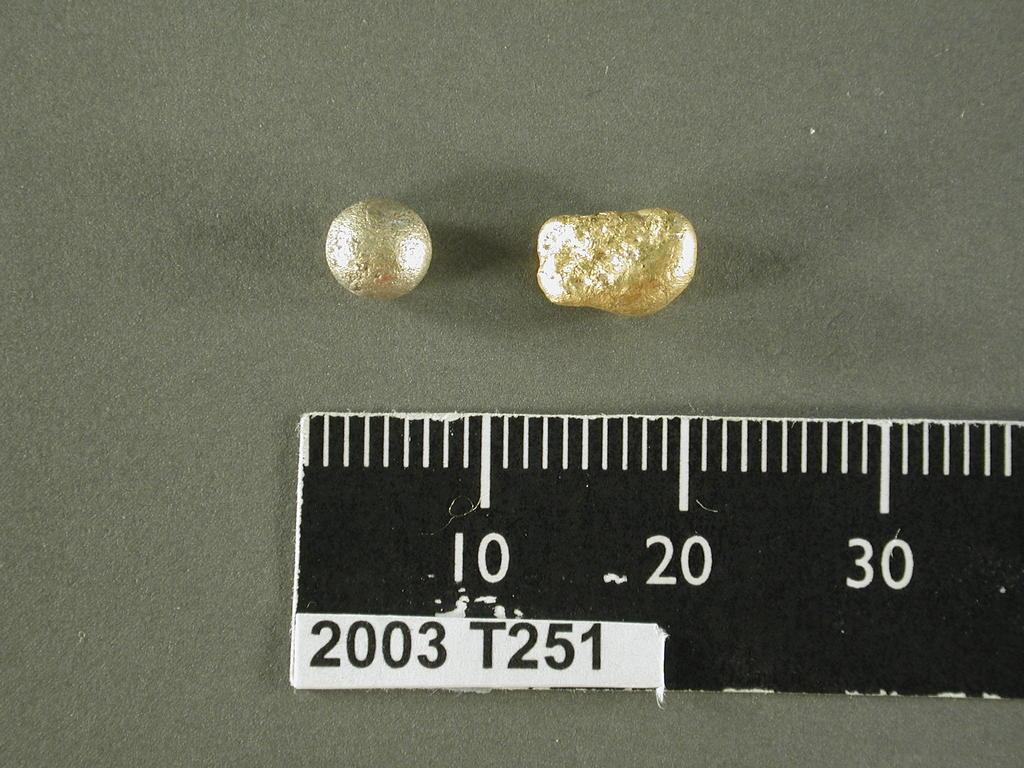<image>
Offer a succinct explanation of the picture presented. a few pearly beads with part of a ruler by them that says 10 and 20. 